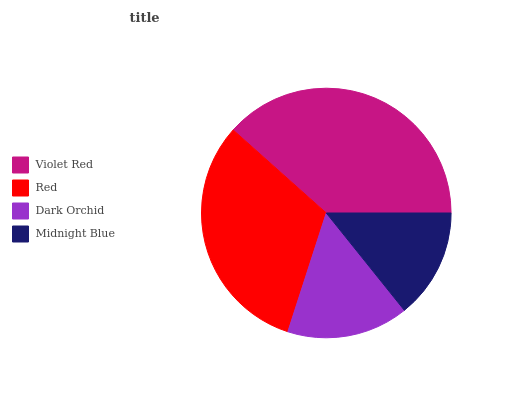Is Midnight Blue the minimum?
Answer yes or no. Yes. Is Violet Red the maximum?
Answer yes or no. Yes. Is Red the minimum?
Answer yes or no. No. Is Red the maximum?
Answer yes or no. No. Is Violet Red greater than Red?
Answer yes or no. Yes. Is Red less than Violet Red?
Answer yes or no. Yes. Is Red greater than Violet Red?
Answer yes or no. No. Is Violet Red less than Red?
Answer yes or no. No. Is Red the high median?
Answer yes or no. Yes. Is Dark Orchid the low median?
Answer yes or no. Yes. Is Dark Orchid the high median?
Answer yes or no. No. Is Violet Red the low median?
Answer yes or no. No. 